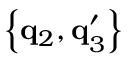<formula> <loc_0><loc_0><loc_500><loc_500>\left \{ q _ { 2 } , q _ { 3 } ^ { \prime } \right \}</formula> 